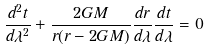<formula> <loc_0><loc_0><loc_500><loc_500>\frac { d ^ { 2 } t } { d \lambda ^ { 2 } } + \frac { 2 G M } { r ( r - 2 G M ) } \frac { d r } { d \lambda } \frac { d t } { d \lambda } = 0</formula> 